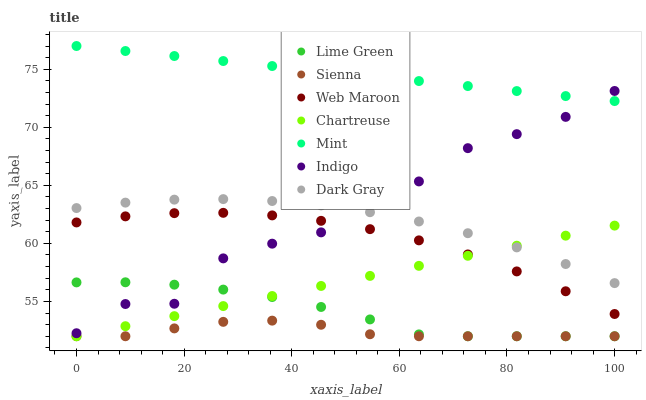Does Sienna have the minimum area under the curve?
Answer yes or no. Yes. Does Mint have the maximum area under the curve?
Answer yes or no. Yes. Does Indigo have the minimum area under the curve?
Answer yes or no. No. Does Indigo have the maximum area under the curve?
Answer yes or no. No. Is Chartreuse the smoothest?
Answer yes or no. Yes. Is Indigo the roughest?
Answer yes or no. Yes. Is Mint the smoothest?
Answer yes or no. No. Is Mint the roughest?
Answer yes or no. No. Does Sienna have the lowest value?
Answer yes or no. Yes. Does Indigo have the lowest value?
Answer yes or no. No. Does Mint have the highest value?
Answer yes or no. Yes. Does Indigo have the highest value?
Answer yes or no. No. Is Chartreuse less than Mint?
Answer yes or no. Yes. Is Mint greater than Chartreuse?
Answer yes or no. Yes. Does Chartreuse intersect Dark Gray?
Answer yes or no. Yes. Is Chartreuse less than Dark Gray?
Answer yes or no. No. Is Chartreuse greater than Dark Gray?
Answer yes or no. No. Does Chartreuse intersect Mint?
Answer yes or no. No. 